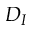Convert formula to latex. <formula><loc_0><loc_0><loc_500><loc_500>D _ { I }</formula> 